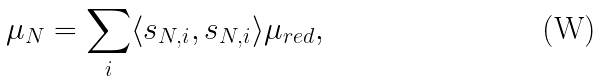Convert formula to latex. <formula><loc_0><loc_0><loc_500><loc_500>\mu _ { N } = \sum _ { i } \langle s _ { N , i } , s _ { N , i } \rangle \mu _ { r e d } ,</formula> 